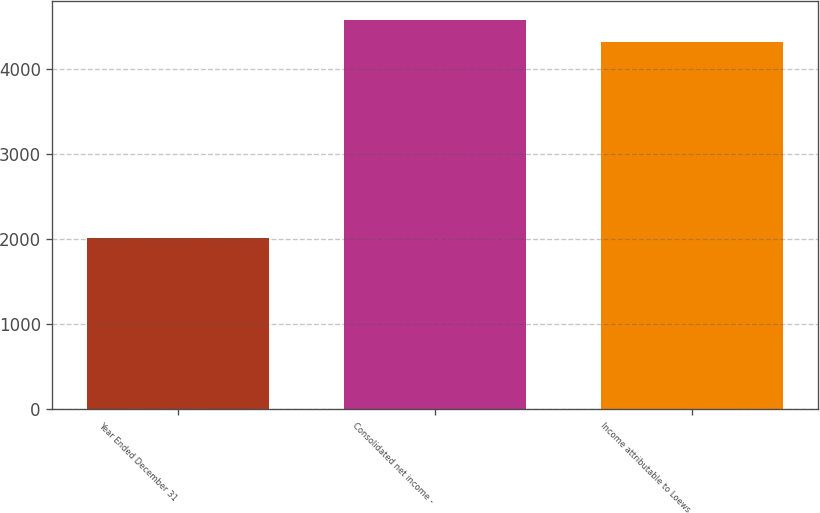<chart> <loc_0><loc_0><loc_500><loc_500><bar_chart><fcel>Year Ended December 31<fcel>Consolidated net income -<fcel>Income attributable to Loews<nl><fcel>2008<fcel>4571.2<fcel>4319<nl></chart> 